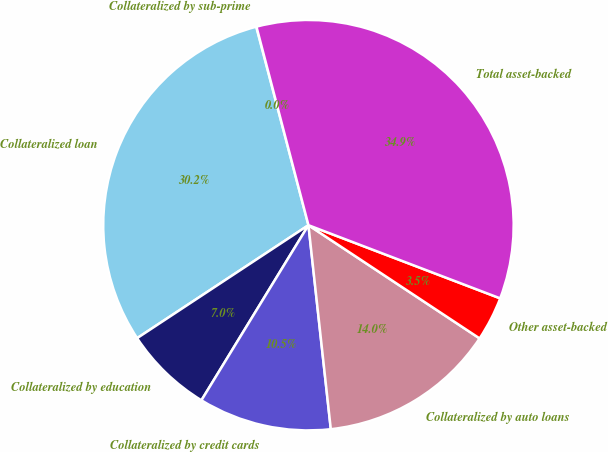Convert chart to OTSL. <chart><loc_0><loc_0><loc_500><loc_500><pie_chart><fcel>Collateralized by sub-prime<fcel>Collateralized loan<fcel>Collateralized by education<fcel>Collateralized by credit cards<fcel>Collateralized by auto loans<fcel>Other asset-backed<fcel>Total asset-backed<nl><fcel>0.02%<fcel>30.18%<fcel>6.99%<fcel>10.47%<fcel>13.96%<fcel>3.5%<fcel>34.88%<nl></chart> 